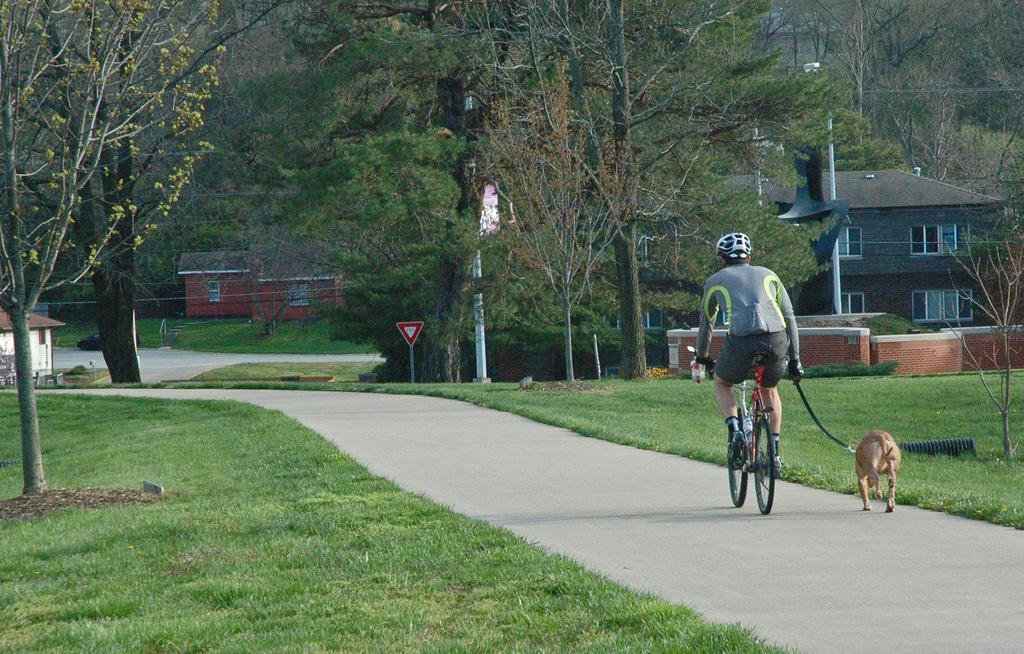In one or two sentences, can you explain what this image depicts? There is a person sitting and riding bicycle and wore helmet and holding a belt and we can see dog running on the road. We can see trees and grass. In the background we can see houses,poles,board,trees and houses. 